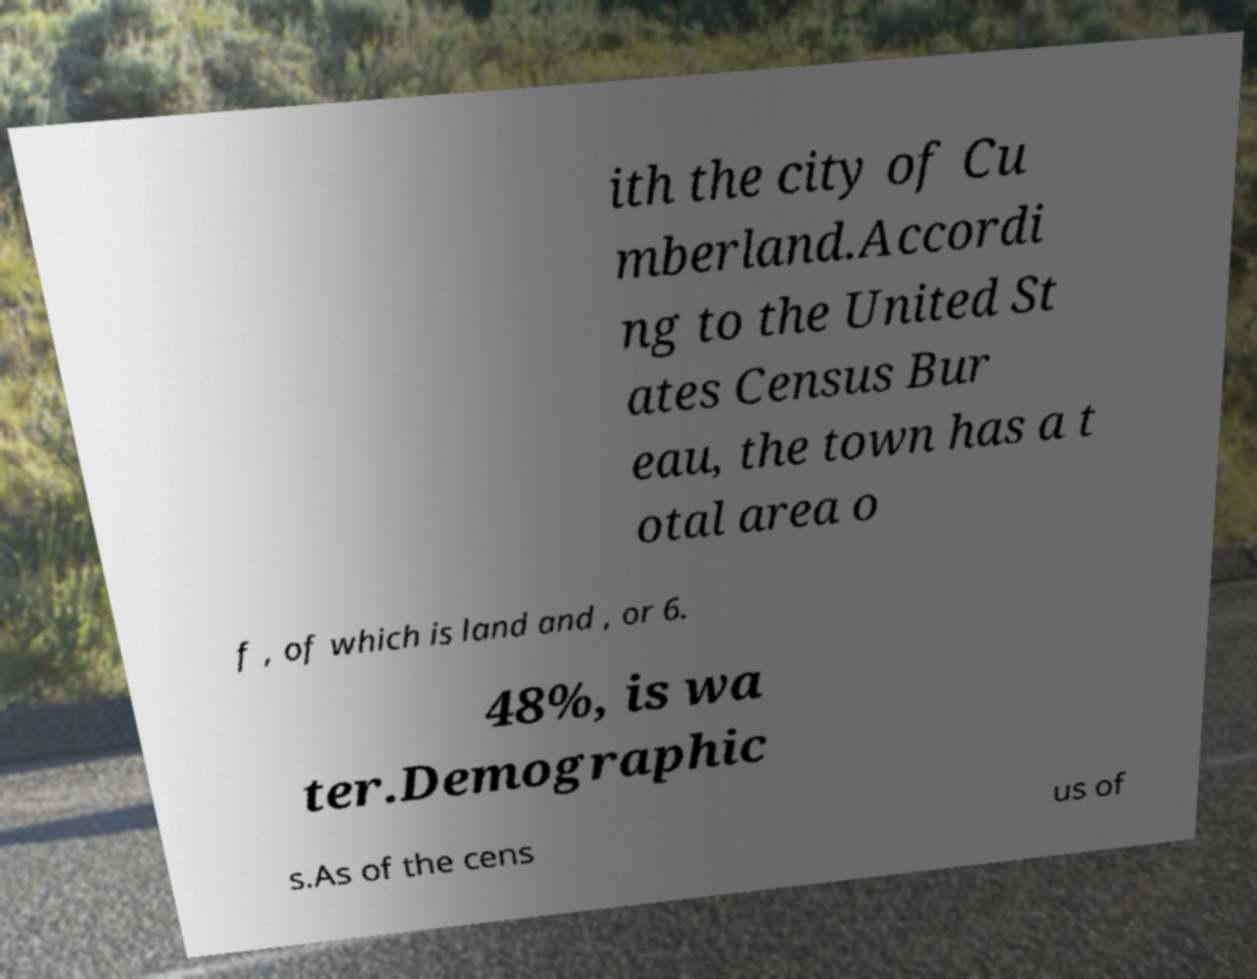Can you accurately transcribe the text from the provided image for me? ith the city of Cu mberland.Accordi ng to the United St ates Census Bur eau, the town has a t otal area o f , of which is land and , or 6. 48%, is wa ter.Demographic s.As of the cens us of 